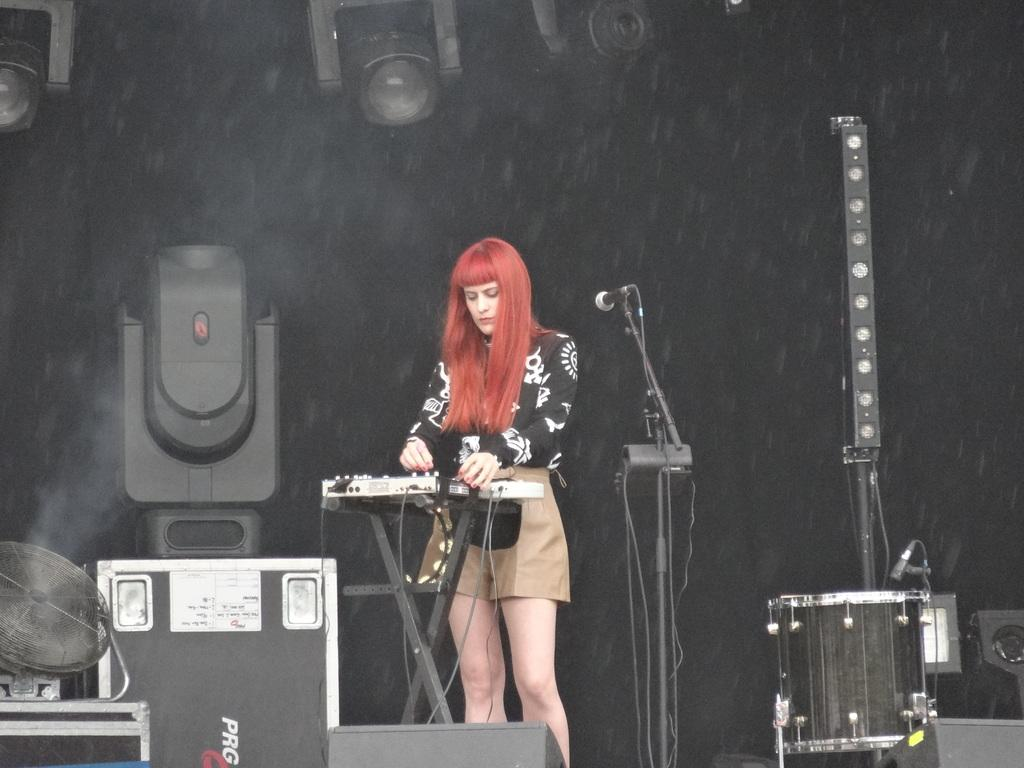What objects are located at the bottom of the image? There are musical instruments, drums, and a microphone at the bottom of the image. What type of musical instruments can be seen in the image? The musical instruments in the image are drums. What is the woman in the image doing? The woman is standing behind the musical instruments. What equipment is visible behind the woman? There are speakers behind the woman. What can be seen in the background of the image? There is a wall visible in the background. What color is the shirt worn by the woman in the image? There is no information about the woman's shirt in the provided facts, so we cannot determine its color. Is there a slope visible in the image? There is no mention of a slope in the provided facts, so we cannot determine if one is present in the image. 